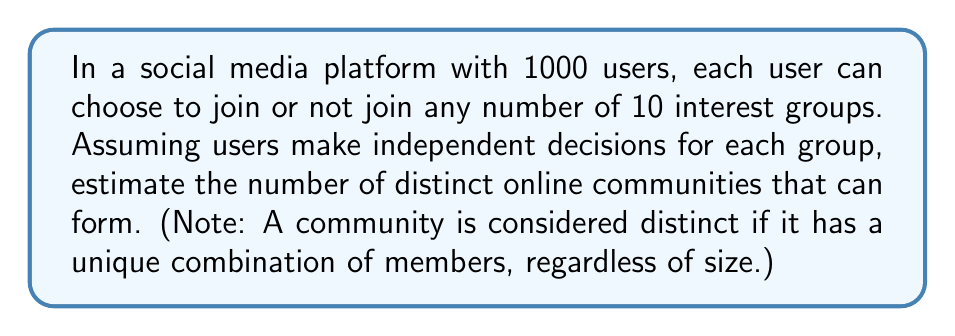Can you solve this math problem? Let's approach this step-by-step:

1) For each interest group, a user has 2 choices: join or not join.

2) Since there are 10 interest groups, each user has $2^{10}$ possible combinations of group memberships.

3) With 1000 users, and each user having $2^{10}$ choices, we might initially think the total number of possibilities is $(2^{10})^{1000}$.

4) However, this overestimates the number of distinct communities. We need to consider that many of these combinations will result in the same community (e.g., if users A and B switch their choices, the resulting community is the same).

5) A more accurate estimate can be obtained using the concept of distinguishable objects. Each of the $2^{10}$ possible combinations of group memberships can be thought of as a distinct "type" of user.

6) The problem then becomes: How many ways can we distribute 1000 indistinguishable users into $2^{10}$ distinguishable types?

7) This is a classic stars and bars problem in combinatorics. The formula for this is:

   $$\binom{n+k-1}{k-1}$$

   where $n$ is the number of indistinguishable objects (users) and $k$ is the number of distinguishable categories (types of users).

8) In our case, $n = 1000$ and $k = 2^{10} = 1024$. So we have:

   $$\binom{1000+1024-1}{1024-1} = \binom{2023}{1023}$$

9) This number is extremely large and can be approximated using Stirling's approximation:

   $$\binom{2023}{1023} \approx \frac{2023^{2023}}{1023^{1023} \cdot 1000^{1000}}$$

10) This gives us an estimate of the number of distinct online communities that can form.
Answer: $\binom{2023}{1023} \approx \frac{2023^{2023}}{1023^{1023} \cdot 1000^{1000}}$ 